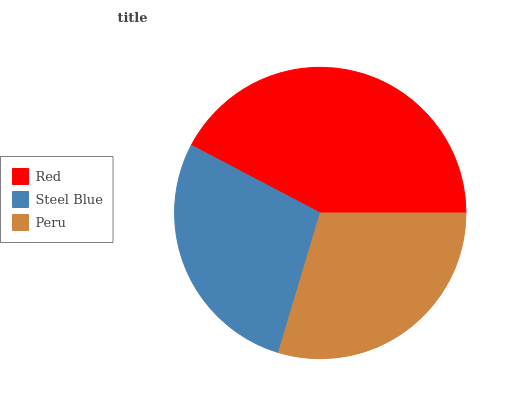Is Steel Blue the minimum?
Answer yes or no. Yes. Is Red the maximum?
Answer yes or no. Yes. Is Peru the minimum?
Answer yes or no. No. Is Peru the maximum?
Answer yes or no. No. Is Peru greater than Steel Blue?
Answer yes or no. Yes. Is Steel Blue less than Peru?
Answer yes or no. Yes. Is Steel Blue greater than Peru?
Answer yes or no. No. Is Peru less than Steel Blue?
Answer yes or no. No. Is Peru the high median?
Answer yes or no. Yes. Is Peru the low median?
Answer yes or no. Yes. Is Steel Blue the high median?
Answer yes or no. No. Is Red the low median?
Answer yes or no. No. 